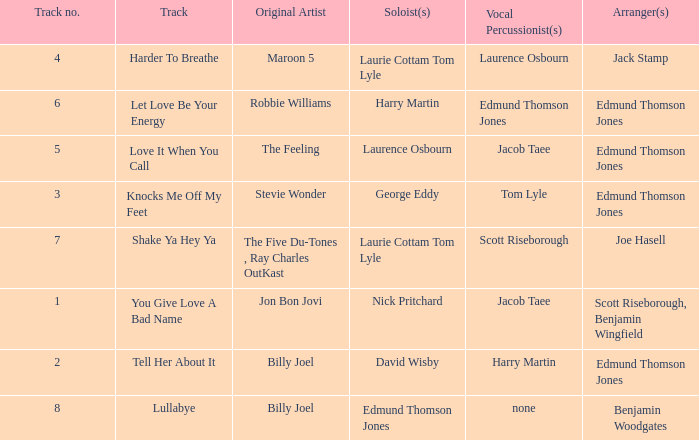Who were the original artist(s) on harder to breathe? Maroon 5. 